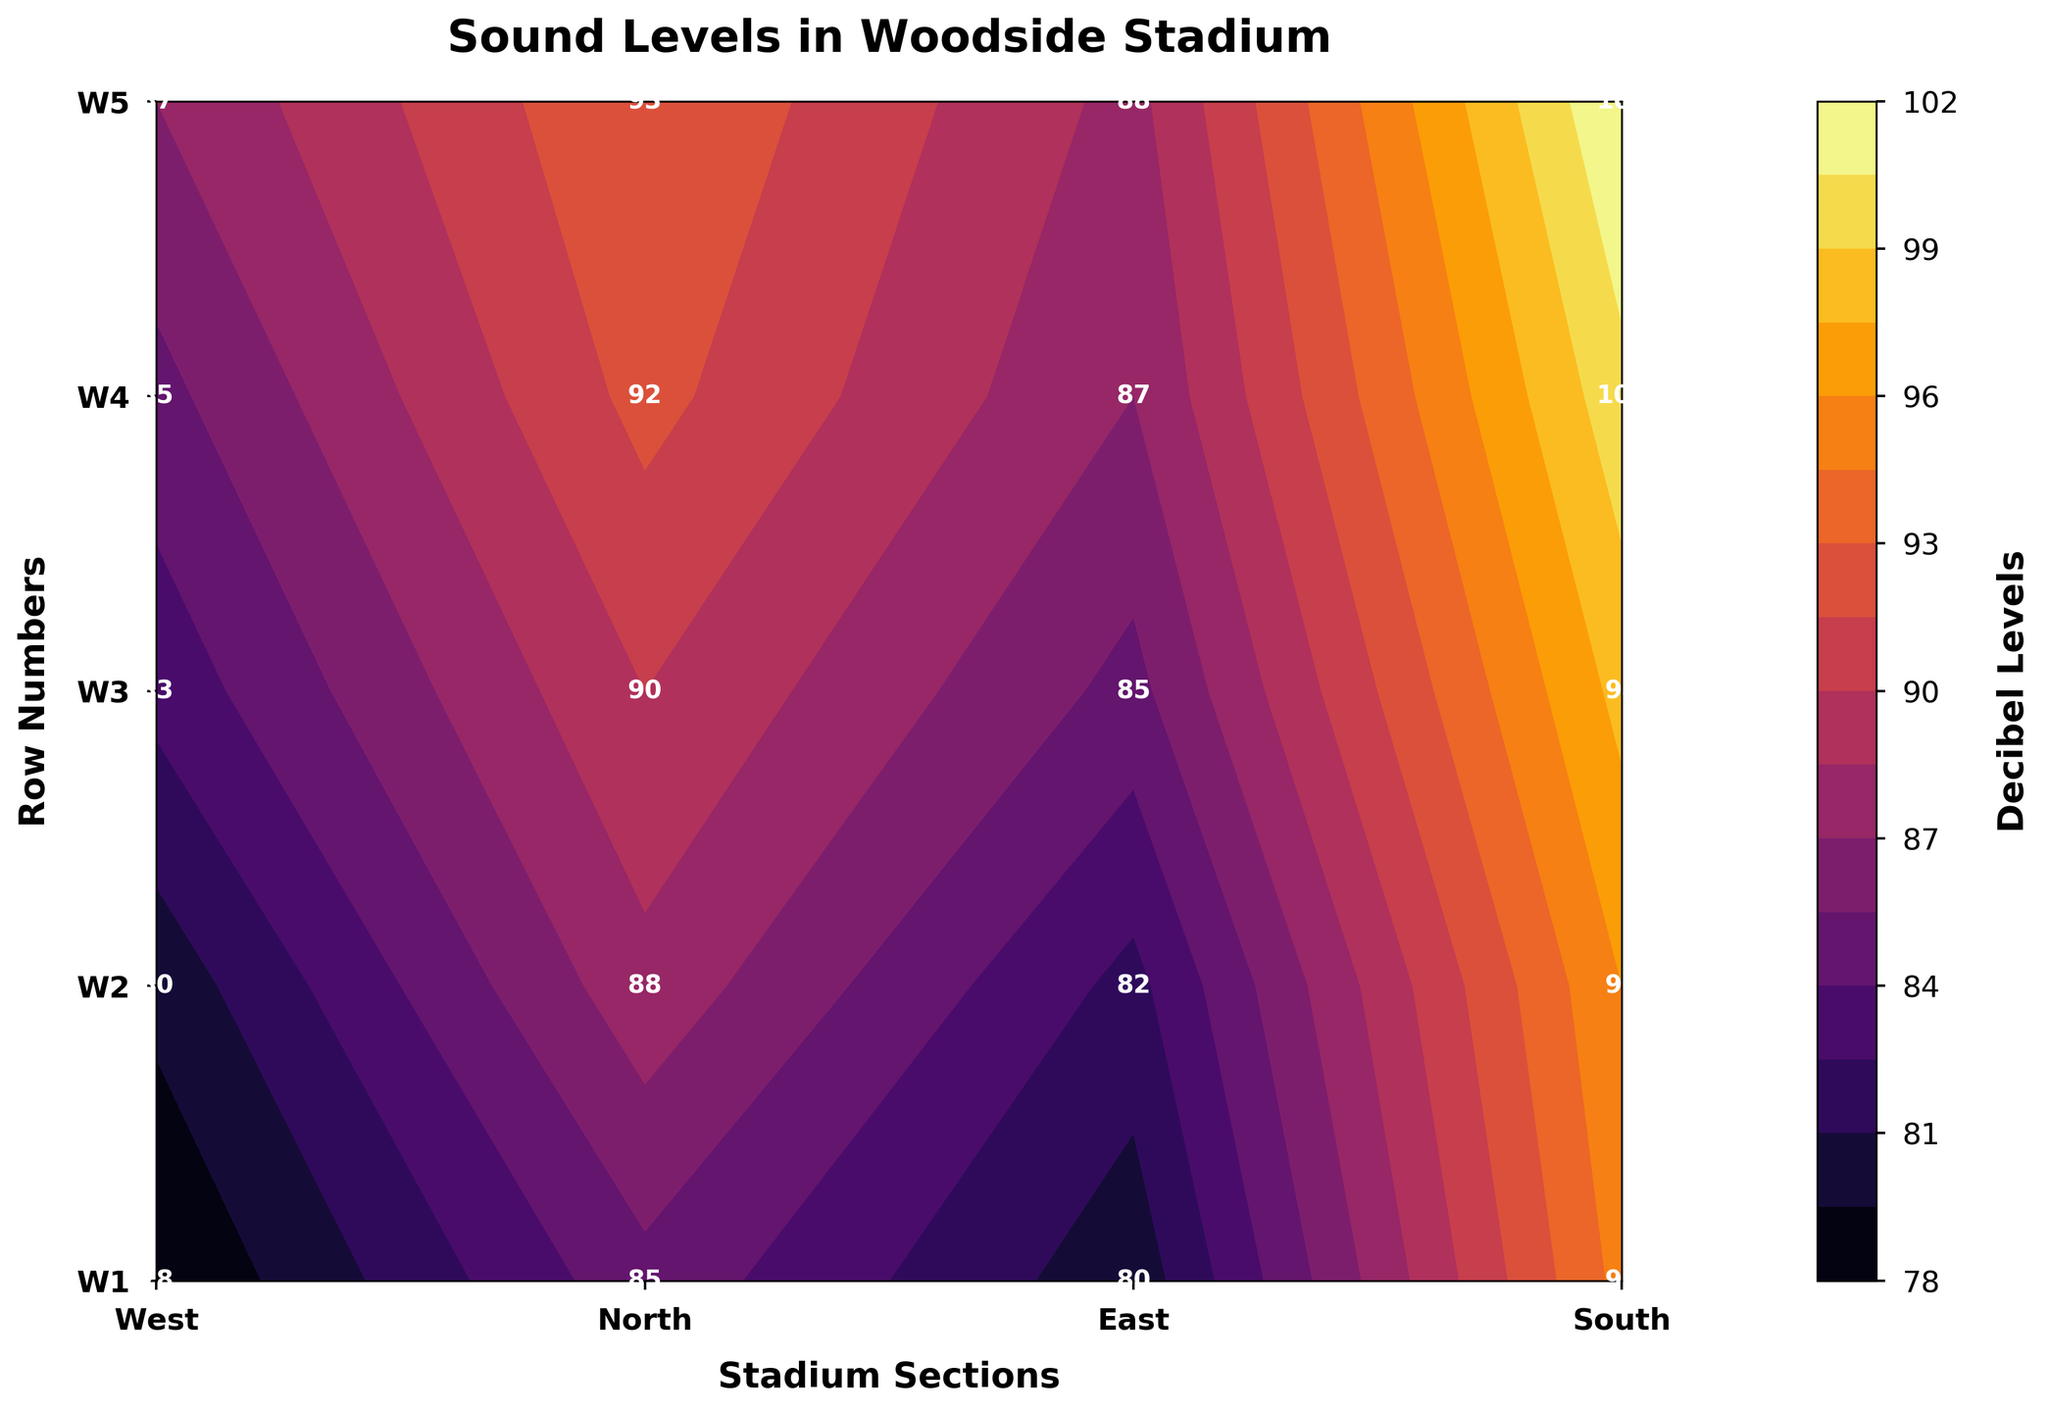What's the title of the plot? The title is located at the top of the plot and is usually in a larger, bold font size. It serves as a brief summary of what the plot is about.
Answer: Sound Levels in Woodside Stadium What is the decibel level at the South section and Row S3? To determine this, locate the South section on the x-axis, and then locate Row S3 on the y-axis. Find the intersecting cell and read the value.
Answer: 98 Which section has the highest recorded decibel level? Scan through each section (West, North, East, and South) and identify the highest value. The highest decibel in this case is 102, which corresponds to the South section.
Answer: South What is the average decibel level recorded in the East section? To find the average, sum the decibel levels in the East section and divide by the number of rows (5). The values are (80 + 82 + 85 + 87 + 88). Sum = 422, thus average = 422 / 5 = 84.4
Answer: 84.4 How do the sound levels in the West section compare to those in the North section? Compare the decibel levels for each row in the West section with the corresponding rows in the North section. Generally, the North section has higher decibel levels compared to the West section. For example, W1 (West) is 78 vs. W1 (North) which is 85. This pattern continues for the other rows as well.
Answer: North section generally has higher decibel levels than West In which section and row is the quietest spot in the stadium? Identify the lowest decibel level in the contour plot. The quietest spot is 78 in the West section Row W1.
Answer: West section, Row W1 Compare the difference in decibel levels between Row W5 in the West section and Row S5 in the South section. Identify the values: W5 in West (87) and S5 in South (102). The difference is 102 - 87 = 15 decibels.
Answer: 15 What pattern do you see in the sound levels when moving from the front (Row 1) to the back (Row 5) of each section? Generally, the decibel levels increase from Row 1 to Row 5 in each section. For example, in the North section, the decibel levels increase from 85 to 93 as you move from W1 to W5.
Answer: Sound levels generally increase from front to back Which section has the most uniform sound levels across its rows? To determine uniformity, look for the smallest range in decibel levels within a section. The East section has values (80, 82, 85, 87, 88) ranging from 80 to 88, which is a smaller range compared to other sections.
Answer: East Do the sound levels in the North section exceed 90 decibels at any row? Check each row in the North section. Rows W4 and W5 in the North section have sound levels of 92 and 93 decibels, respectively, which exceed 90 decibels.
Answer: Yes 